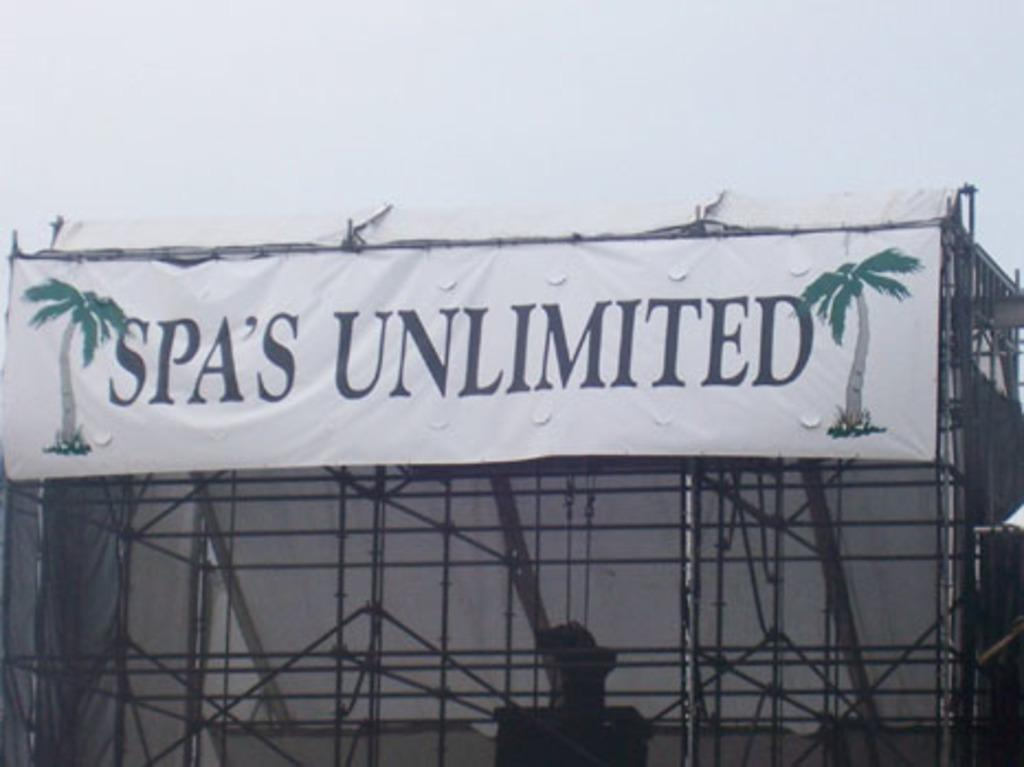<image>
Provide a brief description of the given image. A sign that has palm trees and the word "Spa's Unlimited" on it. 